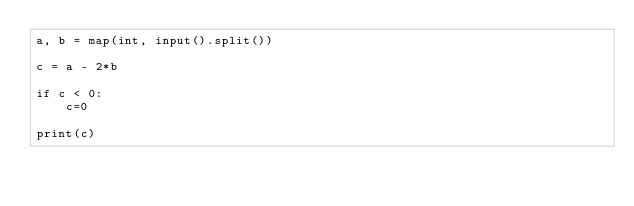<code> <loc_0><loc_0><loc_500><loc_500><_Python_>a, b = map(int, input().split())

c = a - 2*b

if c < 0:
    c=0
    
print(c)
</code> 